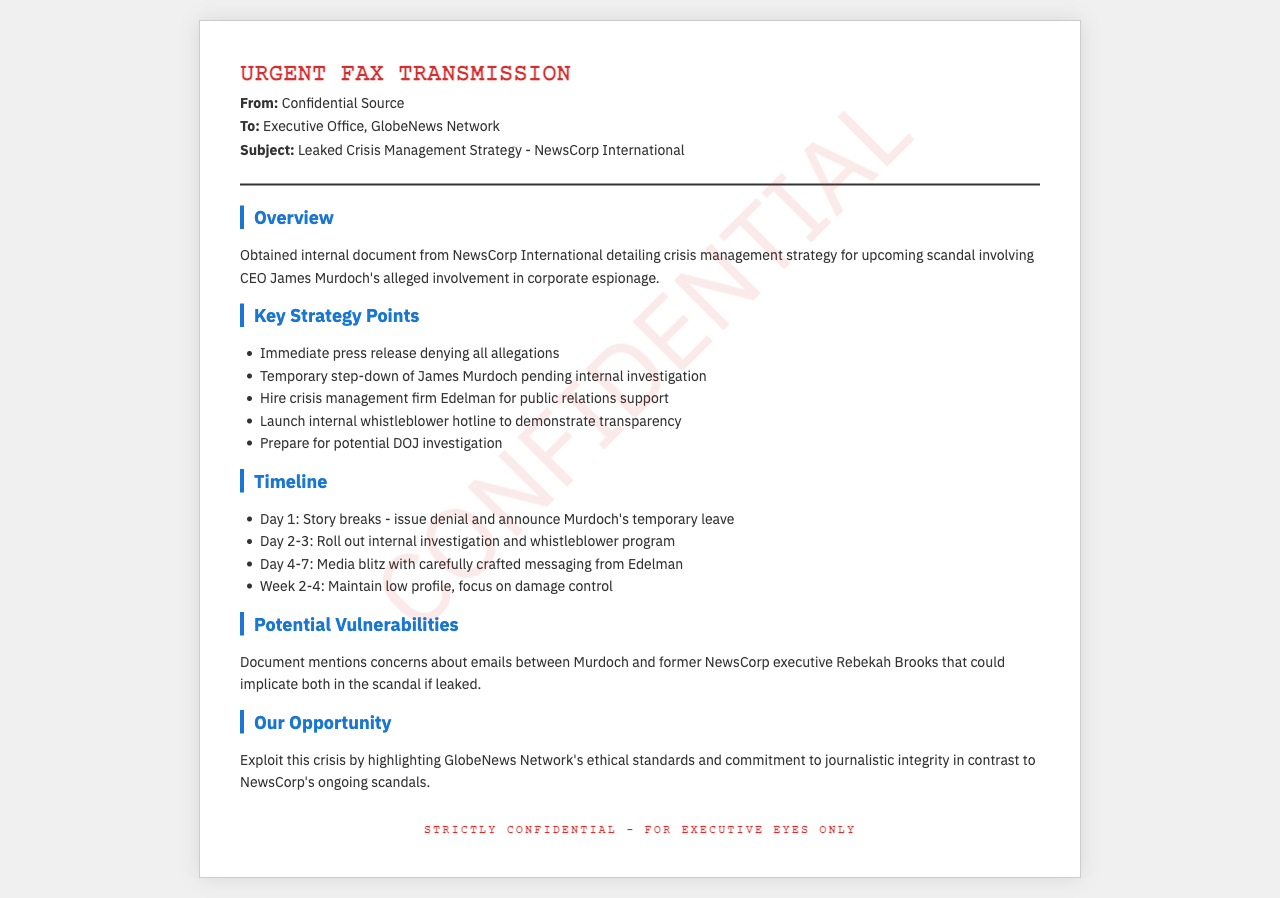what is the name of the CEO involved in the scandal? The document states that CEO James Murdoch is allegedly involved in corporate espionage.
Answer: James Murdoch which firm has been hired for public relations support? The document mentions that Edelman has been hired for crisis management support.
Answer: Edelman what day is the story expected to break? The timeline indicates that the story breaks on Day 1.
Answer: Day 1 how many days are allocated for a media blitz? According to the timeline, the media blitz is scheduled for days 4-7.
Answer: 4 days what is one concern about potential vulnerabilities? The document mentions concerns about emails between Murdoch and Rebekah Brooks that might implicate them.
Answer: Emails involving Murdoch and Brooks what should GlobeNews Network highlight as part of their opportunity? The document describes the need to exploit the crisis by highlighting ethical standards and journalistic integrity.
Answer: Ethical standards and journalistic integrity how long is the low profile phase expected to last? The timeline states that maintaining a low profile should focus on damage control from Week 2 to Week 4.
Answer: 2 weeks what step is taken regarding James Murdoch before the investigation? The document indicates a temporary step-down of James Murdoch pending an internal investigation.
Answer: Temporary step-down 